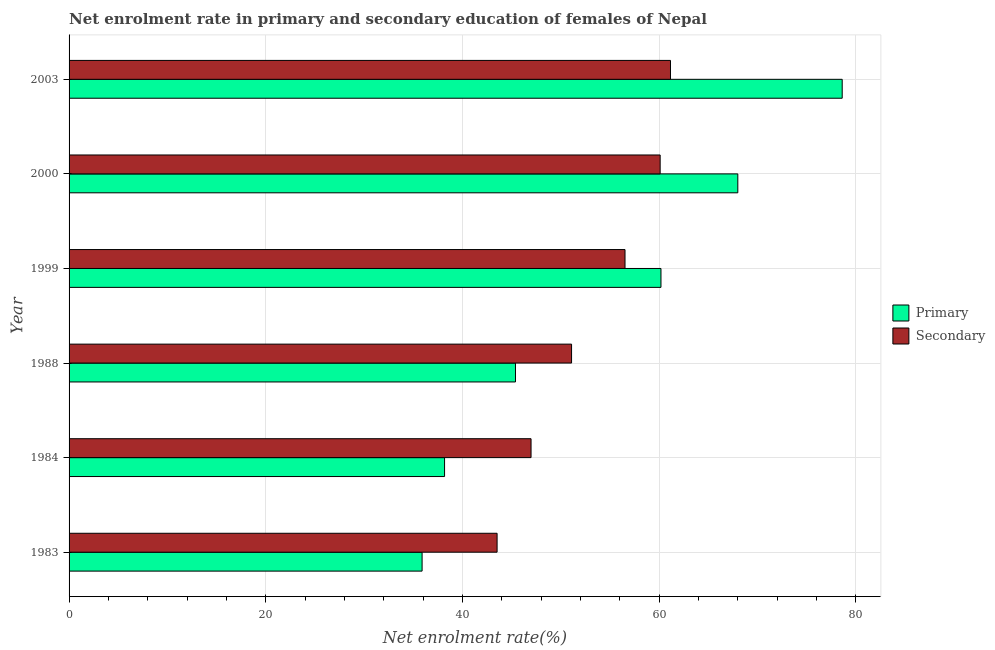How many different coloured bars are there?
Provide a succinct answer. 2. How many groups of bars are there?
Make the answer very short. 6. Are the number of bars per tick equal to the number of legend labels?
Offer a very short reply. Yes. Are the number of bars on each tick of the Y-axis equal?
Your answer should be compact. Yes. How many bars are there on the 2nd tick from the top?
Offer a very short reply. 2. What is the enrollment rate in primary education in 2000?
Offer a very short reply. 67.99. Across all years, what is the maximum enrollment rate in secondary education?
Your response must be concise. 61.15. Across all years, what is the minimum enrollment rate in secondary education?
Provide a short and direct response. 43.52. What is the total enrollment rate in primary education in the graph?
Offer a terse response. 326.23. What is the difference between the enrollment rate in primary education in 1984 and that in 2000?
Give a very brief answer. -29.82. What is the difference between the enrollment rate in primary education in 2000 and the enrollment rate in secondary education in 1999?
Your answer should be very brief. 11.47. What is the average enrollment rate in primary education per year?
Your response must be concise. 54.37. In the year 1983, what is the difference between the enrollment rate in primary education and enrollment rate in secondary education?
Provide a short and direct response. -7.63. What is the ratio of the enrollment rate in secondary education in 1988 to that in 1999?
Your answer should be compact. 0.9. Is the enrollment rate in secondary education in 1984 less than that in 2003?
Your answer should be compact. Yes. Is the difference between the enrollment rate in secondary education in 1983 and 1984 greater than the difference between the enrollment rate in primary education in 1983 and 1984?
Your answer should be compact. No. What is the difference between the highest and the second highest enrollment rate in secondary education?
Provide a short and direct response. 1.05. What is the difference between the highest and the lowest enrollment rate in secondary education?
Provide a succinct answer. 17.63. Is the sum of the enrollment rate in primary education in 1988 and 2003 greater than the maximum enrollment rate in secondary education across all years?
Your response must be concise. Yes. What does the 1st bar from the top in 2003 represents?
Make the answer very short. Secondary. What does the 1st bar from the bottom in 1983 represents?
Your answer should be very brief. Primary. How many bars are there?
Give a very brief answer. 12. Are all the bars in the graph horizontal?
Your response must be concise. Yes. Are the values on the major ticks of X-axis written in scientific E-notation?
Offer a terse response. No. Does the graph contain any zero values?
Your response must be concise. No. Where does the legend appear in the graph?
Your answer should be very brief. Center right. What is the title of the graph?
Your answer should be compact. Net enrolment rate in primary and secondary education of females of Nepal. Does "Young" appear as one of the legend labels in the graph?
Keep it short and to the point. No. What is the label or title of the X-axis?
Give a very brief answer. Net enrolment rate(%). What is the label or title of the Y-axis?
Provide a short and direct response. Year. What is the Net enrolment rate(%) in Primary in 1983?
Offer a very short reply. 35.89. What is the Net enrolment rate(%) in Secondary in 1983?
Ensure brevity in your answer.  43.52. What is the Net enrolment rate(%) of Primary in 1984?
Offer a very short reply. 38.18. What is the Net enrolment rate(%) in Secondary in 1984?
Ensure brevity in your answer.  46.97. What is the Net enrolment rate(%) in Primary in 1988?
Offer a very short reply. 45.39. What is the Net enrolment rate(%) of Secondary in 1988?
Provide a succinct answer. 51.09. What is the Net enrolment rate(%) of Primary in 1999?
Ensure brevity in your answer.  60.18. What is the Net enrolment rate(%) of Secondary in 1999?
Your answer should be very brief. 56.52. What is the Net enrolment rate(%) in Primary in 2000?
Your response must be concise. 67.99. What is the Net enrolment rate(%) in Secondary in 2000?
Keep it short and to the point. 60.1. What is the Net enrolment rate(%) in Primary in 2003?
Offer a terse response. 78.61. What is the Net enrolment rate(%) in Secondary in 2003?
Your answer should be very brief. 61.15. Across all years, what is the maximum Net enrolment rate(%) of Primary?
Ensure brevity in your answer.  78.61. Across all years, what is the maximum Net enrolment rate(%) in Secondary?
Give a very brief answer. 61.15. Across all years, what is the minimum Net enrolment rate(%) of Primary?
Offer a terse response. 35.89. Across all years, what is the minimum Net enrolment rate(%) in Secondary?
Provide a succinct answer. 43.52. What is the total Net enrolment rate(%) in Primary in the graph?
Your answer should be very brief. 326.23. What is the total Net enrolment rate(%) of Secondary in the graph?
Your answer should be very brief. 319.34. What is the difference between the Net enrolment rate(%) of Primary in 1983 and that in 1984?
Give a very brief answer. -2.29. What is the difference between the Net enrolment rate(%) of Secondary in 1983 and that in 1984?
Keep it short and to the point. -3.45. What is the difference between the Net enrolment rate(%) of Primary in 1983 and that in 1988?
Offer a terse response. -9.5. What is the difference between the Net enrolment rate(%) of Secondary in 1983 and that in 1988?
Your answer should be very brief. -7.57. What is the difference between the Net enrolment rate(%) of Primary in 1983 and that in 1999?
Provide a short and direct response. -24.29. What is the difference between the Net enrolment rate(%) of Secondary in 1983 and that in 1999?
Provide a succinct answer. -13.01. What is the difference between the Net enrolment rate(%) in Primary in 1983 and that in 2000?
Your answer should be very brief. -32.1. What is the difference between the Net enrolment rate(%) in Secondary in 1983 and that in 2000?
Offer a very short reply. -16.58. What is the difference between the Net enrolment rate(%) in Primary in 1983 and that in 2003?
Provide a succinct answer. -42.71. What is the difference between the Net enrolment rate(%) in Secondary in 1983 and that in 2003?
Your answer should be very brief. -17.63. What is the difference between the Net enrolment rate(%) in Primary in 1984 and that in 1988?
Your response must be concise. -7.21. What is the difference between the Net enrolment rate(%) of Secondary in 1984 and that in 1988?
Your response must be concise. -4.12. What is the difference between the Net enrolment rate(%) of Primary in 1984 and that in 1999?
Provide a short and direct response. -22. What is the difference between the Net enrolment rate(%) of Secondary in 1984 and that in 1999?
Your answer should be compact. -9.55. What is the difference between the Net enrolment rate(%) in Primary in 1984 and that in 2000?
Your answer should be compact. -29.82. What is the difference between the Net enrolment rate(%) of Secondary in 1984 and that in 2000?
Ensure brevity in your answer.  -13.13. What is the difference between the Net enrolment rate(%) of Primary in 1984 and that in 2003?
Offer a terse response. -40.43. What is the difference between the Net enrolment rate(%) in Secondary in 1984 and that in 2003?
Your answer should be very brief. -14.18. What is the difference between the Net enrolment rate(%) in Primary in 1988 and that in 1999?
Offer a very short reply. -14.79. What is the difference between the Net enrolment rate(%) in Secondary in 1988 and that in 1999?
Ensure brevity in your answer.  -5.43. What is the difference between the Net enrolment rate(%) of Primary in 1988 and that in 2000?
Provide a succinct answer. -22.61. What is the difference between the Net enrolment rate(%) in Secondary in 1988 and that in 2000?
Offer a terse response. -9.01. What is the difference between the Net enrolment rate(%) in Primary in 1988 and that in 2003?
Provide a succinct answer. -33.22. What is the difference between the Net enrolment rate(%) in Secondary in 1988 and that in 2003?
Your response must be concise. -10.06. What is the difference between the Net enrolment rate(%) in Primary in 1999 and that in 2000?
Your response must be concise. -7.81. What is the difference between the Net enrolment rate(%) in Secondary in 1999 and that in 2000?
Keep it short and to the point. -3.57. What is the difference between the Net enrolment rate(%) of Primary in 1999 and that in 2003?
Your answer should be compact. -18.43. What is the difference between the Net enrolment rate(%) in Secondary in 1999 and that in 2003?
Your answer should be very brief. -4.62. What is the difference between the Net enrolment rate(%) of Primary in 2000 and that in 2003?
Ensure brevity in your answer.  -10.61. What is the difference between the Net enrolment rate(%) in Secondary in 2000 and that in 2003?
Provide a short and direct response. -1.05. What is the difference between the Net enrolment rate(%) in Primary in 1983 and the Net enrolment rate(%) in Secondary in 1984?
Provide a succinct answer. -11.08. What is the difference between the Net enrolment rate(%) in Primary in 1983 and the Net enrolment rate(%) in Secondary in 1988?
Your response must be concise. -15.2. What is the difference between the Net enrolment rate(%) of Primary in 1983 and the Net enrolment rate(%) of Secondary in 1999?
Keep it short and to the point. -20.63. What is the difference between the Net enrolment rate(%) in Primary in 1983 and the Net enrolment rate(%) in Secondary in 2000?
Your response must be concise. -24.2. What is the difference between the Net enrolment rate(%) in Primary in 1983 and the Net enrolment rate(%) in Secondary in 2003?
Your answer should be compact. -25.26. What is the difference between the Net enrolment rate(%) in Primary in 1984 and the Net enrolment rate(%) in Secondary in 1988?
Your response must be concise. -12.91. What is the difference between the Net enrolment rate(%) in Primary in 1984 and the Net enrolment rate(%) in Secondary in 1999?
Your answer should be compact. -18.35. What is the difference between the Net enrolment rate(%) of Primary in 1984 and the Net enrolment rate(%) of Secondary in 2000?
Your answer should be compact. -21.92. What is the difference between the Net enrolment rate(%) in Primary in 1984 and the Net enrolment rate(%) in Secondary in 2003?
Your response must be concise. -22.97. What is the difference between the Net enrolment rate(%) of Primary in 1988 and the Net enrolment rate(%) of Secondary in 1999?
Ensure brevity in your answer.  -11.14. What is the difference between the Net enrolment rate(%) of Primary in 1988 and the Net enrolment rate(%) of Secondary in 2000?
Your response must be concise. -14.71. What is the difference between the Net enrolment rate(%) in Primary in 1988 and the Net enrolment rate(%) in Secondary in 2003?
Your answer should be very brief. -15.76. What is the difference between the Net enrolment rate(%) of Primary in 1999 and the Net enrolment rate(%) of Secondary in 2000?
Provide a short and direct response. 0.08. What is the difference between the Net enrolment rate(%) in Primary in 1999 and the Net enrolment rate(%) in Secondary in 2003?
Offer a terse response. -0.97. What is the difference between the Net enrolment rate(%) in Primary in 2000 and the Net enrolment rate(%) in Secondary in 2003?
Ensure brevity in your answer.  6.85. What is the average Net enrolment rate(%) of Primary per year?
Offer a terse response. 54.37. What is the average Net enrolment rate(%) of Secondary per year?
Make the answer very short. 53.22. In the year 1983, what is the difference between the Net enrolment rate(%) in Primary and Net enrolment rate(%) in Secondary?
Your answer should be compact. -7.63. In the year 1984, what is the difference between the Net enrolment rate(%) in Primary and Net enrolment rate(%) in Secondary?
Your response must be concise. -8.79. In the year 1988, what is the difference between the Net enrolment rate(%) of Primary and Net enrolment rate(%) of Secondary?
Your response must be concise. -5.7. In the year 1999, what is the difference between the Net enrolment rate(%) in Primary and Net enrolment rate(%) in Secondary?
Provide a short and direct response. 3.66. In the year 2000, what is the difference between the Net enrolment rate(%) of Primary and Net enrolment rate(%) of Secondary?
Your answer should be very brief. 7.9. In the year 2003, what is the difference between the Net enrolment rate(%) in Primary and Net enrolment rate(%) in Secondary?
Offer a terse response. 17.46. What is the ratio of the Net enrolment rate(%) of Primary in 1983 to that in 1984?
Provide a succinct answer. 0.94. What is the ratio of the Net enrolment rate(%) in Secondary in 1983 to that in 1984?
Offer a very short reply. 0.93. What is the ratio of the Net enrolment rate(%) of Primary in 1983 to that in 1988?
Ensure brevity in your answer.  0.79. What is the ratio of the Net enrolment rate(%) of Secondary in 1983 to that in 1988?
Offer a very short reply. 0.85. What is the ratio of the Net enrolment rate(%) of Primary in 1983 to that in 1999?
Your answer should be very brief. 0.6. What is the ratio of the Net enrolment rate(%) of Secondary in 1983 to that in 1999?
Offer a very short reply. 0.77. What is the ratio of the Net enrolment rate(%) of Primary in 1983 to that in 2000?
Offer a very short reply. 0.53. What is the ratio of the Net enrolment rate(%) of Secondary in 1983 to that in 2000?
Provide a succinct answer. 0.72. What is the ratio of the Net enrolment rate(%) of Primary in 1983 to that in 2003?
Make the answer very short. 0.46. What is the ratio of the Net enrolment rate(%) of Secondary in 1983 to that in 2003?
Keep it short and to the point. 0.71. What is the ratio of the Net enrolment rate(%) of Primary in 1984 to that in 1988?
Provide a short and direct response. 0.84. What is the ratio of the Net enrolment rate(%) of Secondary in 1984 to that in 1988?
Your answer should be very brief. 0.92. What is the ratio of the Net enrolment rate(%) in Primary in 1984 to that in 1999?
Offer a terse response. 0.63. What is the ratio of the Net enrolment rate(%) of Secondary in 1984 to that in 1999?
Your answer should be compact. 0.83. What is the ratio of the Net enrolment rate(%) in Primary in 1984 to that in 2000?
Keep it short and to the point. 0.56. What is the ratio of the Net enrolment rate(%) of Secondary in 1984 to that in 2000?
Offer a terse response. 0.78. What is the ratio of the Net enrolment rate(%) in Primary in 1984 to that in 2003?
Make the answer very short. 0.49. What is the ratio of the Net enrolment rate(%) in Secondary in 1984 to that in 2003?
Give a very brief answer. 0.77. What is the ratio of the Net enrolment rate(%) in Primary in 1988 to that in 1999?
Your response must be concise. 0.75. What is the ratio of the Net enrolment rate(%) in Secondary in 1988 to that in 1999?
Your response must be concise. 0.9. What is the ratio of the Net enrolment rate(%) in Primary in 1988 to that in 2000?
Offer a very short reply. 0.67. What is the ratio of the Net enrolment rate(%) of Secondary in 1988 to that in 2000?
Provide a short and direct response. 0.85. What is the ratio of the Net enrolment rate(%) of Primary in 1988 to that in 2003?
Keep it short and to the point. 0.58. What is the ratio of the Net enrolment rate(%) of Secondary in 1988 to that in 2003?
Give a very brief answer. 0.84. What is the ratio of the Net enrolment rate(%) in Primary in 1999 to that in 2000?
Provide a short and direct response. 0.89. What is the ratio of the Net enrolment rate(%) of Secondary in 1999 to that in 2000?
Make the answer very short. 0.94. What is the ratio of the Net enrolment rate(%) in Primary in 1999 to that in 2003?
Offer a terse response. 0.77. What is the ratio of the Net enrolment rate(%) of Secondary in 1999 to that in 2003?
Ensure brevity in your answer.  0.92. What is the ratio of the Net enrolment rate(%) in Primary in 2000 to that in 2003?
Provide a succinct answer. 0.86. What is the ratio of the Net enrolment rate(%) in Secondary in 2000 to that in 2003?
Give a very brief answer. 0.98. What is the difference between the highest and the second highest Net enrolment rate(%) of Primary?
Keep it short and to the point. 10.61. What is the difference between the highest and the second highest Net enrolment rate(%) in Secondary?
Provide a short and direct response. 1.05. What is the difference between the highest and the lowest Net enrolment rate(%) of Primary?
Ensure brevity in your answer.  42.71. What is the difference between the highest and the lowest Net enrolment rate(%) in Secondary?
Keep it short and to the point. 17.63. 